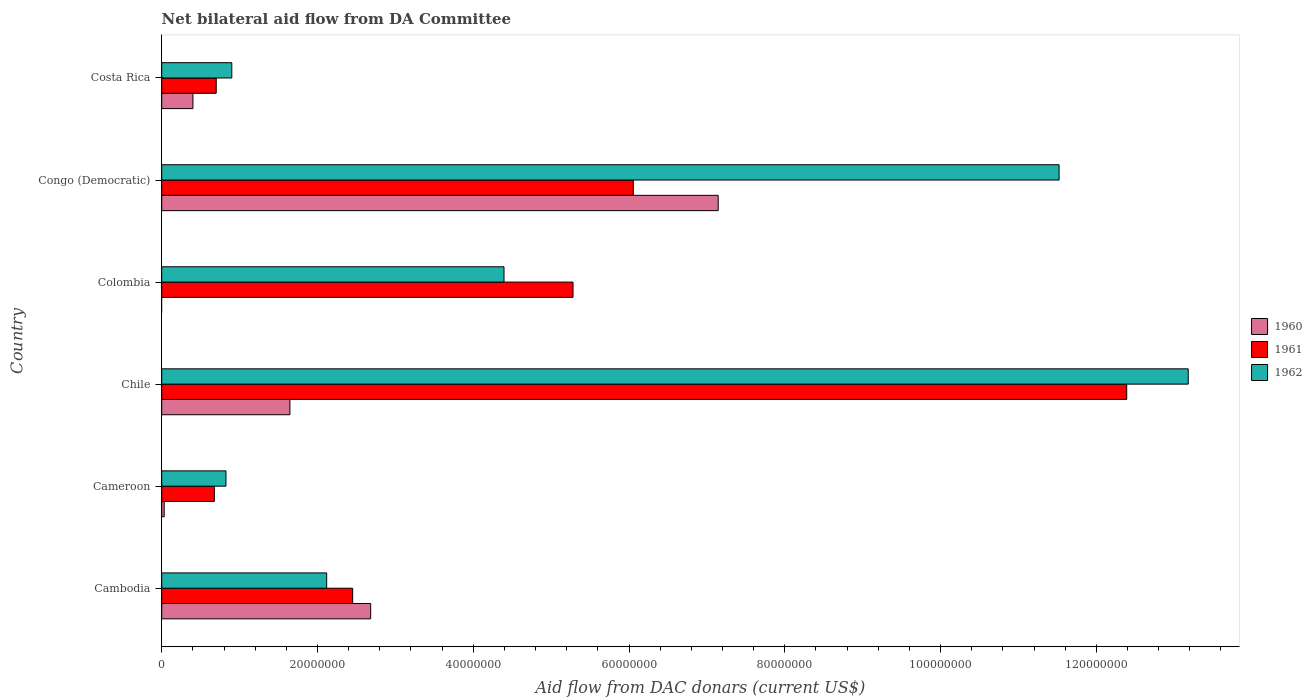What is the label of the 2nd group of bars from the top?
Your answer should be very brief. Congo (Democratic). What is the aid flow in in 1960 in Chile?
Offer a terse response. 1.65e+07. Across all countries, what is the maximum aid flow in in 1962?
Your answer should be compact. 1.32e+08. Across all countries, what is the minimum aid flow in in 1961?
Offer a terse response. 6.76e+06. In which country was the aid flow in in 1962 maximum?
Keep it short and to the point. Chile. What is the total aid flow in in 1960 in the graph?
Provide a short and direct response. 1.19e+08. What is the difference between the aid flow in in 1962 in Chile and that in Costa Rica?
Your answer should be very brief. 1.23e+08. What is the difference between the aid flow in in 1961 in Cambodia and the aid flow in in 1962 in Congo (Democratic)?
Ensure brevity in your answer.  -9.07e+07. What is the average aid flow in in 1960 per country?
Give a very brief answer. 1.98e+07. What is the difference between the aid flow in in 1960 and aid flow in in 1961 in Costa Rica?
Your response must be concise. -2.99e+06. In how many countries, is the aid flow in in 1962 greater than 36000000 US$?
Provide a short and direct response. 3. What is the ratio of the aid flow in in 1962 in Cambodia to that in Colombia?
Offer a very short reply. 0.48. Is the aid flow in in 1962 in Cameroon less than that in Chile?
Your answer should be compact. Yes. Is the difference between the aid flow in in 1960 in Cameroon and Chile greater than the difference between the aid flow in in 1961 in Cameroon and Chile?
Give a very brief answer. Yes. What is the difference between the highest and the second highest aid flow in in 1961?
Provide a succinct answer. 6.34e+07. What is the difference between the highest and the lowest aid flow in in 1962?
Ensure brevity in your answer.  1.24e+08. Is it the case that in every country, the sum of the aid flow in in 1961 and aid flow in in 1960 is greater than the aid flow in in 1962?
Make the answer very short. No. How many bars are there?
Offer a very short reply. 17. What is the difference between two consecutive major ticks on the X-axis?
Your response must be concise. 2.00e+07. Where does the legend appear in the graph?
Offer a very short reply. Center right. How many legend labels are there?
Your answer should be very brief. 3. How are the legend labels stacked?
Keep it short and to the point. Vertical. What is the title of the graph?
Your answer should be compact. Net bilateral aid flow from DA Committee. What is the label or title of the X-axis?
Your response must be concise. Aid flow from DAC donars (current US$). What is the label or title of the Y-axis?
Ensure brevity in your answer.  Country. What is the Aid flow from DAC donars (current US$) of 1960 in Cambodia?
Your answer should be very brief. 2.68e+07. What is the Aid flow from DAC donars (current US$) in 1961 in Cambodia?
Your answer should be very brief. 2.45e+07. What is the Aid flow from DAC donars (current US$) of 1962 in Cambodia?
Your answer should be compact. 2.12e+07. What is the Aid flow from DAC donars (current US$) of 1960 in Cameroon?
Keep it short and to the point. 3.20e+05. What is the Aid flow from DAC donars (current US$) in 1961 in Cameroon?
Make the answer very short. 6.76e+06. What is the Aid flow from DAC donars (current US$) of 1962 in Cameroon?
Offer a very short reply. 8.25e+06. What is the Aid flow from DAC donars (current US$) in 1960 in Chile?
Keep it short and to the point. 1.65e+07. What is the Aid flow from DAC donars (current US$) of 1961 in Chile?
Your response must be concise. 1.24e+08. What is the Aid flow from DAC donars (current US$) of 1962 in Chile?
Ensure brevity in your answer.  1.32e+08. What is the Aid flow from DAC donars (current US$) in 1961 in Colombia?
Offer a terse response. 5.28e+07. What is the Aid flow from DAC donars (current US$) of 1962 in Colombia?
Keep it short and to the point. 4.40e+07. What is the Aid flow from DAC donars (current US$) of 1960 in Congo (Democratic)?
Your response must be concise. 7.14e+07. What is the Aid flow from DAC donars (current US$) of 1961 in Congo (Democratic)?
Provide a succinct answer. 6.06e+07. What is the Aid flow from DAC donars (current US$) of 1962 in Congo (Democratic)?
Offer a terse response. 1.15e+08. What is the Aid flow from DAC donars (current US$) of 1960 in Costa Rica?
Your response must be concise. 4.01e+06. What is the Aid flow from DAC donars (current US$) of 1961 in Costa Rica?
Keep it short and to the point. 7.00e+06. What is the Aid flow from DAC donars (current US$) of 1962 in Costa Rica?
Your answer should be compact. 9.00e+06. Across all countries, what is the maximum Aid flow from DAC donars (current US$) in 1960?
Keep it short and to the point. 7.14e+07. Across all countries, what is the maximum Aid flow from DAC donars (current US$) in 1961?
Keep it short and to the point. 1.24e+08. Across all countries, what is the maximum Aid flow from DAC donars (current US$) in 1962?
Keep it short and to the point. 1.32e+08. Across all countries, what is the minimum Aid flow from DAC donars (current US$) of 1961?
Provide a succinct answer. 6.76e+06. Across all countries, what is the minimum Aid flow from DAC donars (current US$) of 1962?
Your answer should be very brief. 8.25e+06. What is the total Aid flow from DAC donars (current US$) of 1960 in the graph?
Provide a short and direct response. 1.19e+08. What is the total Aid flow from DAC donars (current US$) of 1961 in the graph?
Your answer should be compact. 2.76e+08. What is the total Aid flow from DAC donars (current US$) in 1962 in the graph?
Your response must be concise. 3.29e+08. What is the difference between the Aid flow from DAC donars (current US$) in 1960 in Cambodia and that in Cameroon?
Offer a very short reply. 2.65e+07. What is the difference between the Aid flow from DAC donars (current US$) of 1961 in Cambodia and that in Cameroon?
Your answer should be compact. 1.78e+07. What is the difference between the Aid flow from DAC donars (current US$) in 1962 in Cambodia and that in Cameroon?
Make the answer very short. 1.29e+07. What is the difference between the Aid flow from DAC donars (current US$) in 1960 in Cambodia and that in Chile?
Make the answer very short. 1.04e+07. What is the difference between the Aid flow from DAC donars (current US$) in 1961 in Cambodia and that in Chile?
Offer a very short reply. -9.94e+07. What is the difference between the Aid flow from DAC donars (current US$) in 1962 in Cambodia and that in Chile?
Make the answer very short. -1.11e+08. What is the difference between the Aid flow from DAC donars (current US$) of 1961 in Cambodia and that in Colombia?
Offer a terse response. -2.83e+07. What is the difference between the Aid flow from DAC donars (current US$) of 1962 in Cambodia and that in Colombia?
Provide a short and direct response. -2.28e+07. What is the difference between the Aid flow from DAC donars (current US$) in 1960 in Cambodia and that in Congo (Democratic)?
Provide a succinct answer. -4.46e+07. What is the difference between the Aid flow from DAC donars (current US$) of 1961 in Cambodia and that in Congo (Democratic)?
Your answer should be very brief. -3.60e+07. What is the difference between the Aid flow from DAC donars (current US$) of 1962 in Cambodia and that in Congo (Democratic)?
Ensure brevity in your answer.  -9.40e+07. What is the difference between the Aid flow from DAC donars (current US$) of 1960 in Cambodia and that in Costa Rica?
Ensure brevity in your answer.  2.28e+07. What is the difference between the Aid flow from DAC donars (current US$) of 1961 in Cambodia and that in Costa Rica?
Provide a succinct answer. 1.75e+07. What is the difference between the Aid flow from DAC donars (current US$) of 1962 in Cambodia and that in Costa Rica?
Your answer should be compact. 1.22e+07. What is the difference between the Aid flow from DAC donars (current US$) of 1960 in Cameroon and that in Chile?
Provide a succinct answer. -1.61e+07. What is the difference between the Aid flow from DAC donars (current US$) of 1961 in Cameroon and that in Chile?
Offer a terse response. -1.17e+08. What is the difference between the Aid flow from DAC donars (current US$) of 1962 in Cameroon and that in Chile?
Make the answer very short. -1.24e+08. What is the difference between the Aid flow from DAC donars (current US$) of 1961 in Cameroon and that in Colombia?
Your answer should be compact. -4.60e+07. What is the difference between the Aid flow from DAC donars (current US$) in 1962 in Cameroon and that in Colombia?
Provide a succinct answer. -3.57e+07. What is the difference between the Aid flow from DAC donars (current US$) in 1960 in Cameroon and that in Congo (Democratic)?
Make the answer very short. -7.11e+07. What is the difference between the Aid flow from DAC donars (current US$) in 1961 in Cameroon and that in Congo (Democratic)?
Ensure brevity in your answer.  -5.38e+07. What is the difference between the Aid flow from DAC donars (current US$) in 1962 in Cameroon and that in Congo (Democratic)?
Offer a terse response. -1.07e+08. What is the difference between the Aid flow from DAC donars (current US$) of 1960 in Cameroon and that in Costa Rica?
Offer a terse response. -3.69e+06. What is the difference between the Aid flow from DAC donars (current US$) of 1962 in Cameroon and that in Costa Rica?
Offer a terse response. -7.50e+05. What is the difference between the Aid flow from DAC donars (current US$) of 1961 in Chile and that in Colombia?
Your answer should be very brief. 7.11e+07. What is the difference between the Aid flow from DAC donars (current US$) in 1962 in Chile and that in Colombia?
Ensure brevity in your answer.  8.78e+07. What is the difference between the Aid flow from DAC donars (current US$) of 1960 in Chile and that in Congo (Democratic)?
Your response must be concise. -5.50e+07. What is the difference between the Aid flow from DAC donars (current US$) of 1961 in Chile and that in Congo (Democratic)?
Provide a short and direct response. 6.34e+07. What is the difference between the Aid flow from DAC donars (current US$) of 1962 in Chile and that in Congo (Democratic)?
Offer a very short reply. 1.66e+07. What is the difference between the Aid flow from DAC donars (current US$) of 1960 in Chile and that in Costa Rica?
Keep it short and to the point. 1.24e+07. What is the difference between the Aid flow from DAC donars (current US$) of 1961 in Chile and that in Costa Rica?
Ensure brevity in your answer.  1.17e+08. What is the difference between the Aid flow from DAC donars (current US$) in 1962 in Chile and that in Costa Rica?
Your answer should be compact. 1.23e+08. What is the difference between the Aid flow from DAC donars (current US$) in 1961 in Colombia and that in Congo (Democratic)?
Your answer should be very brief. -7.74e+06. What is the difference between the Aid flow from DAC donars (current US$) of 1962 in Colombia and that in Congo (Democratic)?
Your answer should be compact. -7.13e+07. What is the difference between the Aid flow from DAC donars (current US$) of 1961 in Colombia and that in Costa Rica?
Provide a succinct answer. 4.58e+07. What is the difference between the Aid flow from DAC donars (current US$) in 1962 in Colombia and that in Costa Rica?
Your answer should be very brief. 3.50e+07. What is the difference between the Aid flow from DAC donars (current US$) of 1960 in Congo (Democratic) and that in Costa Rica?
Provide a succinct answer. 6.74e+07. What is the difference between the Aid flow from DAC donars (current US$) of 1961 in Congo (Democratic) and that in Costa Rica?
Provide a short and direct response. 5.36e+07. What is the difference between the Aid flow from DAC donars (current US$) in 1962 in Congo (Democratic) and that in Costa Rica?
Your answer should be very brief. 1.06e+08. What is the difference between the Aid flow from DAC donars (current US$) of 1960 in Cambodia and the Aid flow from DAC donars (current US$) of 1961 in Cameroon?
Make the answer very short. 2.01e+07. What is the difference between the Aid flow from DAC donars (current US$) in 1960 in Cambodia and the Aid flow from DAC donars (current US$) in 1962 in Cameroon?
Offer a very short reply. 1.86e+07. What is the difference between the Aid flow from DAC donars (current US$) of 1961 in Cambodia and the Aid flow from DAC donars (current US$) of 1962 in Cameroon?
Your answer should be compact. 1.63e+07. What is the difference between the Aid flow from DAC donars (current US$) of 1960 in Cambodia and the Aid flow from DAC donars (current US$) of 1961 in Chile?
Give a very brief answer. -9.71e+07. What is the difference between the Aid flow from DAC donars (current US$) in 1960 in Cambodia and the Aid flow from DAC donars (current US$) in 1962 in Chile?
Provide a succinct answer. -1.05e+08. What is the difference between the Aid flow from DAC donars (current US$) in 1961 in Cambodia and the Aid flow from DAC donars (current US$) in 1962 in Chile?
Make the answer very short. -1.07e+08. What is the difference between the Aid flow from DAC donars (current US$) of 1960 in Cambodia and the Aid flow from DAC donars (current US$) of 1961 in Colombia?
Your response must be concise. -2.60e+07. What is the difference between the Aid flow from DAC donars (current US$) of 1960 in Cambodia and the Aid flow from DAC donars (current US$) of 1962 in Colombia?
Ensure brevity in your answer.  -1.71e+07. What is the difference between the Aid flow from DAC donars (current US$) in 1961 in Cambodia and the Aid flow from DAC donars (current US$) in 1962 in Colombia?
Keep it short and to the point. -1.94e+07. What is the difference between the Aid flow from DAC donars (current US$) in 1960 in Cambodia and the Aid flow from DAC donars (current US$) in 1961 in Congo (Democratic)?
Offer a terse response. -3.37e+07. What is the difference between the Aid flow from DAC donars (current US$) in 1960 in Cambodia and the Aid flow from DAC donars (current US$) in 1962 in Congo (Democratic)?
Provide a succinct answer. -8.84e+07. What is the difference between the Aid flow from DAC donars (current US$) in 1961 in Cambodia and the Aid flow from DAC donars (current US$) in 1962 in Congo (Democratic)?
Offer a terse response. -9.07e+07. What is the difference between the Aid flow from DAC donars (current US$) of 1960 in Cambodia and the Aid flow from DAC donars (current US$) of 1961 in Costa Rica?
Give a very brief answer. 1.98e+07. What is the difference between the Aid flow from DAC donars (current US$) in 1960 in Cambodia and the Aid flow from DAC donars (current US$) in 1962 in Costa Rica?
Your answer should be compact. 1.78e+07. What is the difference between the Aid flow from DAC donars (current US$) in 1961 in Cambodia and the Aid flow from DAC donars (current US$) in 1962 in Costa Rica?
Ensure brevity in your answer.  1.55e+07. What is the difference between the Aid flow from DAC donars (current US$) in 1960 in Cameroon and the Aid flow from DAC donars (current US$) in 1961 in Chile?
Offer a terse response. -1.24e+08. What is the difference between the Aid flow from DAC donars (current US$) of 1960 in Cameroon and the Aid flow from DAC donars (current US$) of 1962 in Chile?
Make the answer very short. -1.31e+08. What is the difference between the Aid flow from DAC donars (current US$) in 1961 in Cameroon and the Aid flow from DAC donars (current US$) in 1962 in Chile?
Keep it short and to the point. -1.25e+08. What is the difference between the Aid flow from DAC donars (current US$) in 1960 in Cameroon and the Aid flow from DAC donars (current US$) in 1961 in Colombia?
Provide a succinct answer. -5.25e+07. What is the difference between the Aid flow from DAC donars (current US$) of 1960 in Cameroon and the Aid flow from DAC donars (current US$) of 1962 in Colombia?
Your answer should be compact. -4.36e+07. What is the difference between the Aid flow from DAC donars (current US$) in 1961 in Cameroon and the Aid flow from DAC donars (current US$) in 1962 in Colombia?
Provide a succinct answer. -3.72e+07. What is the difference between the Aid flow from DAC donars (current US$) in 1960 in Cameroon and the Aid flow from DAC donars (current US$) in 1961 in Congo (Democratic)?
Offer a very short reply. -6.02e+07. What is the difference between the Aid flow from DAC donars (current US$) of 1960 in Cameroon and the Aid flow from DAC donars (current US$) of 1962 in Congo (Democratic)?
Offer a terse response. -1.15e+08. What is the difference between the Aid flow from DAC donars (current US$) of 1961 in Cameroon and the Aid flow from DAC donars (current US$) of 1962 in Congo (Democratic)?
Keep it short and to the point. -1.08e+08. What is the difference between the Aid flow from DAC donars (current US$) in 1960 in Cameroon and the Aid flow from DAC donars (current US$) in 1961 in Costa Rica?
Provide a short and direct response. -6.68e+06. What is the difference between the Aid flow from DAC donars (current US$) in 1960 in Cameroon and the Aid flow from DAC donars (current US$) in 1962 in Costa Rica?
Provide a short and direct response. -8.68e+06. What is the difference between the Aid flow from DAC donars (current US$) in 1961 in Cameroon and the Aid flow from DAC donars (current US$) in 1962 in Costa Rica?
Give a very brief answer. -2.24e+06. What is the difference between the Aid flow from DAC donars (current US$) in 1960 in Chile and the Aid flow from DAC donars (current US$) in 1961 in Colombia?
Your answer should be very brief. -3.64e+07. What is the difference between the Aid flow from DAC donars (current US$) of 1960 in Chile and the Aid flow from DAC donars (current US$) of 1962 in Colombia?
Your answer should be compact. -2.75e+07. What is the difference between the Aid flow from DAC donars (current US$) in 1961 in Chile and the Aid flow from DAC donars (current US$) in 1962 in Colombia?
Provide a short and direct response. 8.00e+07. What is the difference between the Aid flow from DAC donars (current US$) of 1960 in Chile and the Aid flow from DAC donars (current US$) of 1961 in Congo (Democratic)?
Offer a terse response. -4.41e+07. What is the difference between the Aid flow from DAC donars (current US$) in 1960 in Chile and the Aid flow from DAC donars (current US$) in 1962 in Congo (Democratic)?
Your answer should be very brief. -9.88e+07. What is the difference between the Aid flow from DAC donars (current US$) of 1961 in Chile and the Aid flow from DAC donars (current US$) of 1962 in Congo (Democratic)?
Your response must be concise. 8.68e+06. What is the difference between the Aid flow from DAC donars (current US$) in 1960 in Chile and the Aid flow from DAC donars (current US$) in 1961 in Costa Rica?
Ensure brevity in your answer.  9.46e+06. What is the difference between the Aid flow from DAC donars (current US$) in 1960 in Chile and the Aid flow from DAC donars (current US$) in 1962 in Costa Rica?
Your response must be concise. 7.46e+06. What is the difference between the Aid flow from DAC donars (current US$) in 1961 in Chile and the Aid flow from DAC donars (current US$) in 1962 in Costa Rica?
Provide a succinct answer. 1.15e+08. What is the difference between the Aid flow from DAC donars (current US$) of 1961 in Colombia and the Aid flow from DAC donars (current US$) of 1962 in Congo (Democratic)?
Your response must be concise. -6.24e+07. What is the difference between the Aid flow from DAC donars (current US$) in 1961 in Colombia and the Aid flow from DAC donars (current US$) in 1962 in Costa Rica?
Your answer should be very brief. 4.38e+07. What is the difference between the Aid flow from DAC donars (current US$) of 1960 in Congo (Democratic) and the Aid flow from DAC donars (current US$) of 1961 in Costa Rica?
Keep it short and to the point. 6.44e+07. What is the difference between the Aid flow from DAC donars (current US$) of 1960 in Congo (Democratic) and the Aid flow from DAC donars (current US$) of 1962 in Costa Rica?
Keep it short and to the point. 6.24e+07. What is the difference between the Aid flow from DAC donars (current US$) of 1961 in Congo (Democratic) and the Aid flow from DAC donars (current US$) of 1962 in Costa Rica?
Offer a terse response. 5.16e+07. What is the average Aid flow from DAC donars (current US$) in 1960 per country?
Keep it short and to the point. 1.98e+07. What is the average Aid flow from DAC donars (current US$) of 1961 per country?
Your answer should be compact. 4.59e+07. What is the average Aid flow from DAC donars (current US$) in 1962 per country?
Ensure brevity in your answer.  5.49e+07. What is the difference between the Aid flow from DAC donars (current US$) in 1960 and Aid flow from DAC donars (current US$) in 1961 in Cambodia?
Your response must be concise. 2.31e+06. What is the difference between the Aid flow from DAC donars (current US$) of 1960 and Aid flow from DAC donars (current US$) of 1962 in Cambodia?
Your response must be concise. 5.65e+06. What is the difference between the Aid flow from DAC donars (current US$) in 1961 and Aid flow from DAC donars (current US$) in 1962 in Cambodia?
Your response must be concise. 3.34e+06. What is the difference between the Aid flow from DAC donars (current US$) of 1960 and Aid flow from DAC donars (current US$) of 1961 in Cameroon?
Give a very brief answer. -6.44e+06. What is the difference between the Aid flow from DAC donars (current US$) in 1960 and Aid flow from DAC donars (current US$) in 1962 in Cameroon?
Your response must be concise. -7.93e+06. What is the difference between the Aid flow from DAC donars (current US$) of 1961 and Aid flow from DAC donars (current US$) of 1962 in Cameroon?
Your response must be concise. -1.49e+06. What is the difference between the Aid flow from DAC donars (current US$) in 1960 and Aid flow from DAC donars (current US$) in 1961 in Chile?
Keep it short and to the point. -1.07e+08. What is the difference between the Aid flow from DAC donars (current US$) of 1960 and Aid flow from DAC donars (current US$) of 1962 in Chile?
Provide a succinct answer. -1.15e+08. What is the difference between the Aid flow from DAC donars (current US$) of 1961 and Aid flow from DAC donars (current US$) of 1962 in Chile?
Give a very brief answer. -7.90e+06. What is the difference between the Aid flow from DAC donars (current US$) in 1961 and Aid flow from DAC donars (current US$) in 1962 in Colombia?
Offer a terse response. 8.86e+06. What is the difference between the Aid flow from DAC donars (current US$) in 1960 and Aid flow from DAC donars (current US$) in 1961 in Congo (Democratic)?
Offer a very short reply. 1.09e+07. What is the difference between the Aid flow from DAC donars (current US$) of 1960 and Aid flow from DAC donars (current US$) of 1962 in Congo (Democratic)?
Ensure brevity in your answer.  -4.38e+07. What is the difference between the Aid flow from DAC donars (current US$) of 1961 and Aid flow from DAC donars (current US$) of 1962 in Congo (Democratic)?
Your response must be concise. -5.47e+07. What is the difference between the Aid flow from DAC donars (current US$) of 1960 and Aid flow from DAC donars (current US$) of 1961 in Costa Rica?
Offer a very short reply. -2.99e+06. What is the difference between the Aid flow from DAC donars (current US$) of 1960 and Aid flow from DAC donars (current US$) of 1962 in Costa Rica?
Keep it short and to the point. -4.99e+06. What is the difference between the Aid flow from DAC donars (current US$) of 1961 and Aid flow from DAC donars (current US$) of 1962 in Costa Rica?
Your answer should be compact. -2.00e+06. What is the ratio of the Aid flow from DAC donars (current US$) in 1960 in Cambodia to that in Cameroon?
Your response must be concise. 83.84. What is the ratio of the Aid flow from DAC donars (current US$) of 1961 in Cambodia to that in Cameroon?
Keep it short and to the point. 3.63. What is the ratio of the Aid flow from DAC donars (current US$) in 1962 in Cambodia to that in Cameroon?
Your response must be concise. 2.57. What is the ratio of the Aid flow from DAC donars (current US$) in 1960 in Cambodia to that in Chile?
Provide a short and direct response. 1.63. What is the ratio of the Aid flow from DAC donars (current US$) of 1961 in Cambodia to that in Chile?
Offer a terse response. 0.2. What is the ratio of the Aid flow from DAC donars (current US$) of 1962 in Cambodia to that in Chile?
Offer a very short reply. 0.16. What is the ratio of the Aid flow from DAC donars (current US$) in 1961 in Cambodia to that in Colombia?
Provide a succinct answer. 0.46. What is the ratio of the Aid flow from DAC donars (current US$) of 1962 in Cambodia to that in Colombia?
Offer a very short reply. 0.48. What is the ratio of the Aid flow from DAC donars (current US$) in 1960 in Cambodia to that in Congo (Democratic)?
Your answer should be compact. 0.38. What is the ratio of the Aid flow from DAC donars (current US$) of 1961 in Cambodia to that in Congo (Democratic)?
Provide a succinct answer. 0.41. What is the ratio of the Aid flow from DAC donars (current US$) in 1962 in Cambodia to that in Congo (Democratic)?
Offer a very short reply. 0.18. What is the ratio of the Aid flow from DAC donars (current US$) in 1960 in Cambodia to that in Costa Rica?
Provide a succinct answer. 6.69. What is the ratio of the Aid flow from DAC donars (current US$) of 1961 in Cambodia to that in Costa Rica?
Ensure brevity in your answer.  3.5. What is the ratio of the Aid flow from DAC donars (current US$) in 1962 in Cambodia to that in Costa Rica?
Your answer should be very brief. 2.35. What is the ratio of the Aid flow from DAC donars (current US$) in 1960 in Cameroon to that in Chile?
Keep it short and to the point. 0.02. What is the ratio of the Aid flow from DAC donars (current US$) of 1961 in Cameroon to that in Chile?
Your response must be concise. 0.05. What is the ratio of the Aid flow from DAC donars (current US$) of 1962 in Cameroon to that in Chile?
Ensure brevity in your answer.  0.06. What is the ratio of the Aid flow from DAC donars (current US$) in 1961 in Cameroon to that in Colombia?
Your response must be concise. 0.13. What is the ratio of the Aid flow from DAC donars (current US$) in 1962 in Cameroon to that in Colombia?
Ensure brevity in your answer.  0.19. What is the ratio of the Aid flow from DAC donars (current US$) of 1960 in Cameroon to that in Congo (Democratic)?
Offer a terse response. 0. What is the ratio of the Aid flow from DAC donars (current US$) of 1961 in Cameroon to that in Congo (Democratic)?
Ensure brevity in your answer.  0.11. What is the ratio of the Aid flow from DAC donars (current US$) in 1962 in Cameroon to that in Congo (Democratic)?
Your answer should be compact. 0.07. What is the ratio of the Aid flow from DAC donars (current US$) in 1960 in Cameroon to that in Costa Rica?
Your answer should be compact. 0.08. What is the ratio of the Aid flow from DAC donars (current US$) in 1961 in Cameroon to that in Costa Rica?
Ensure brevity in your answer.  0.97. What is the ratio of the Aid flow from DAC donars (current US$) of 1962 in Cameroon to that in Costa Rica?
Make the answer very short. 0.92. What is the ratio of the Aid flow from DAC donars (current US$) in 1961 in Chile to that in Colombia?
Offer a terse response. 2.35. What is the ratio of the Aid flow from DAC donars (current US$) of 1962 in Chile to that in Colombia?
Ensure brevity in your answer.  3. What is the ratio of the Aid flow from DAC donars (current US$) of 1960 in Chile to that in Congo (Democratic)?
Your response must be concise. 0.23. What is the ratio of the Aid flow from DAC donars (current US$) in 1961 in Chile to that in Congo (Democratic)?
Your answer should be compact. 2.05. What is the ratio of the Aid flow from DAC donars (current US$) of 1962 in Chile to that in Congo (Democratic)?
Keep it short and to the point. 1.14. What is the ratio of the Aid flow from DAC donars (current US$) of 1960 in Chile to that in Costa Rica?
Make the answer very short. 4.1. What is the ratio of the Aid flow from DAC donars (current US$) in 1961 in Chile to that in Costa Rica?
Offer a very short reply. 17.7. What is the ratio of the Aid flow from DAC donars (current US$) in 1962 in Chile to that in Costa Rica?
Your answer should be compact. 14.64. What is the ratio of the Aid flow from DAC donars (current US$) of 1961 in Colombia to that in Congo (Democratic)?
Your answer should be very brief. 0.87. What is the ratio of the Aid flow from DAC donars (current US$) in 1962 in Colombia to that in Congo (Democratic)?
Provide a succinct answer. 0.38. What is the ratio of the Aid flow from DAC donars (current US$) in 1961 in Colombia to that in Costa Rica?
Provide a short and direct response. 7.54. What is the ratio of the Aid flow from DAC donars (current US$) in 1962 in Colombia to that in Costa Rica?
Provide a short and direct response. 4.88. What is the ratio of the Aid flow from DAC donars (current US$) of 1960 in Congo (Democratic) to that in Costa Rica?
Offer a very short reply. 17.82. What is the ratio of the Aid flow from DAC donars (current US$) in 1961 in Congo (Democratic) to that in Costa Rica?
Give a very brief answer. 8.65. What is the ratio of the Aid flow from DAC donars (current US$) of 1962 in Congo (Democratic) to that in Costa Rica?
Make the answer very short. 12.8. What is the difference between the highest and the second highest Aid flow from DAC donars (current US$) in 1960?
Offer a terse response. 4.46e+07. What is the difference between the highest and the second highest Aid flow from DAC donars (current US$) in 1961?
Make the answer very short. 6.34e+07. What is the difference between the highest and the second highest Aid flow from DAC donars (current US$) of 1962?
Your answer should be compact. 1.66e+07. What is the difference between the highest and the lowest Aid flow from DAC donars (current US$) of 1960?
Provide a short and direct response. 7.14e+07. What is the difference between the highest and the lowest Aid flow from DAC donars (current US$) in 1961?
Provide a short and direct response. 1.17e+08. What is the difference between the highest and the lowest Aid flow from DAC donars (current US$) of 1962?
Your response must be concise. 1.24e+08. 